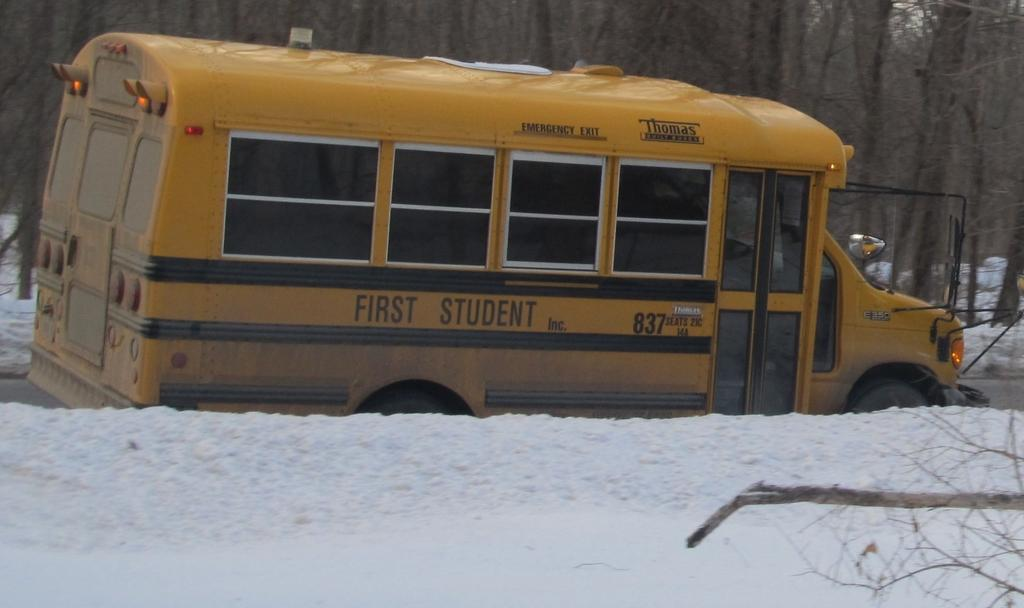<image>
Relay a brief, clear account of the picture shown. A "First Student" school bus parked next to a snow bank 